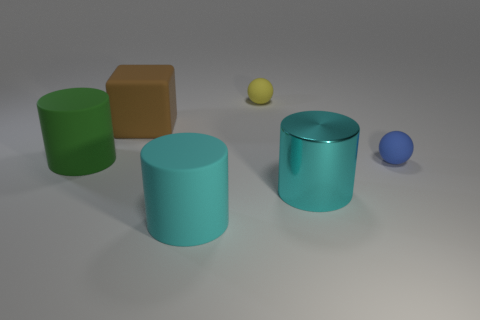Is there anything else that is the same color as the large block?
Provide a short and direct response. No. What color is the large shiny cylinder on the left side of the rubber sphere that is in front of the big green thing?
Your answer should be compact. Cyan. There is a tiny thing that is behind the big matte cylinder left of the cyan matte object in front of the green cylinder; what is its material?
Provide a succinct answer. Rubber. How many matte blocks are the same size as the yellow rubber ball?
Offer a very short reply. 0. What is the large object that is both behind the large cyan matte object and in front of the green rubber object made of?
Your answer should be compact. Metal. There is a large green cylinder; what number of big brown blocks are behind it?
Offer a terse response. 1. There is a tiny blue rubber object; does it have the same shape as the large cyan object on the right side of the cyan matte cylinder?
Provide a short and direct response. No. Is there a brown thing that has the same shape as the yellow thing?
Your answer should be very brief. No. What shape is the cyan thing to the right of the large rubber cylinder to the right of the big cube?
Offer a very short reply. Cylinder. What is the shape of the small object that is on the right side of the tiny yellow ball?
Make the answer very short. Sphere. 